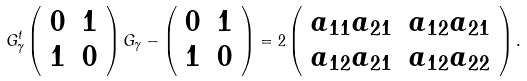<formula> <loc_0><loc_0><loc_500><loc_500>G _ { \gamma } ^ { t } \left ( \begin{array} { c } 0 \\ 1 \end{array} \begin{array} { c c } 1 \\ 0 \end{array} \right ) G _ { \gamma } - \left ( \begin{array} { c } 0 \\ 1 \end{array} \begin{array} { c c } 1 \\ 0 \end{array} \right ) = 2 \left ( \begin{array} { c } a _ { 1 1 } a _ { 2 1 } \\ a _ { 1 2 } a _ { 2 1 } \end{array} \begin{array} { c c } a _ { 1 2 } a _ { 2 1 } \\ a _ { 1 2 } a _ { 2 2 } \end{array} \right ) .</formula> 